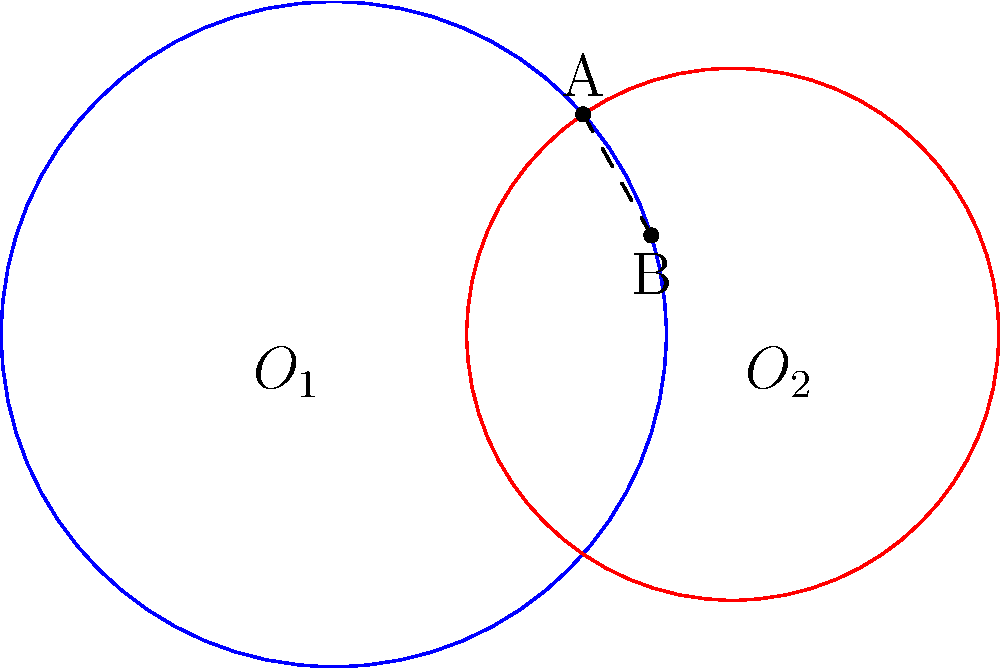In a sculptural installation, two circular forms intersect to create a harmonious composition. The centers of these circles, $O_1$ and $O_2$, are 3 units apart. The radius of the first circle is 2.5 units, and the radius of the second circle is 2 units. What is the length of the common chord AB formed by the intersection of these two circles? Let's approach this step-by-step:

1) First, we need to use the formula for the length of a common chord between two intersecting circles. The formula is:

   $$AB^2 = 4\left(\frac{d^2-(r_1^2-r_2^2)^2}{4d^2}\right)$$

   Where $d$ is the distance between the centers, and $r_1$ and $r_2$ are the radii of the circles.

2) We know that:
   $d = 3$ (distance between centers)
   $r_1 = 2.5$ (radius of first circle)
   $r_2 = 2$ (radius of second circle)

3) Let's substitute these values into the formula:

   $$AB^2 = 4\left(\frac{3^2-(2.5^2-2^2)^2}{4(3^2)}\right)$$

4) Simplify the numerator:
   $3^2 = 9$
   $2.5^2 = 6.25$
   $2^2 = 4$
   $(6.25 - 4)^2 = 2.25^2 = 5.0625$

   $$AB^2 = 4\left(\frac{9-5.0625}{36}\right)$$

5) Continue simplifying:

   $$AB^2 = 4\left(\frac{3.9375}{36}\right) = 4(0.109375) = 0.4375$$

6) To find AB, we take the square root of both sides:

   $$AB = \sqrt{0.4375} \approx 0.6614$$

Thus, the length of the common chord AB is approximately 0.6614 units.
Answer: 0.6614 units 